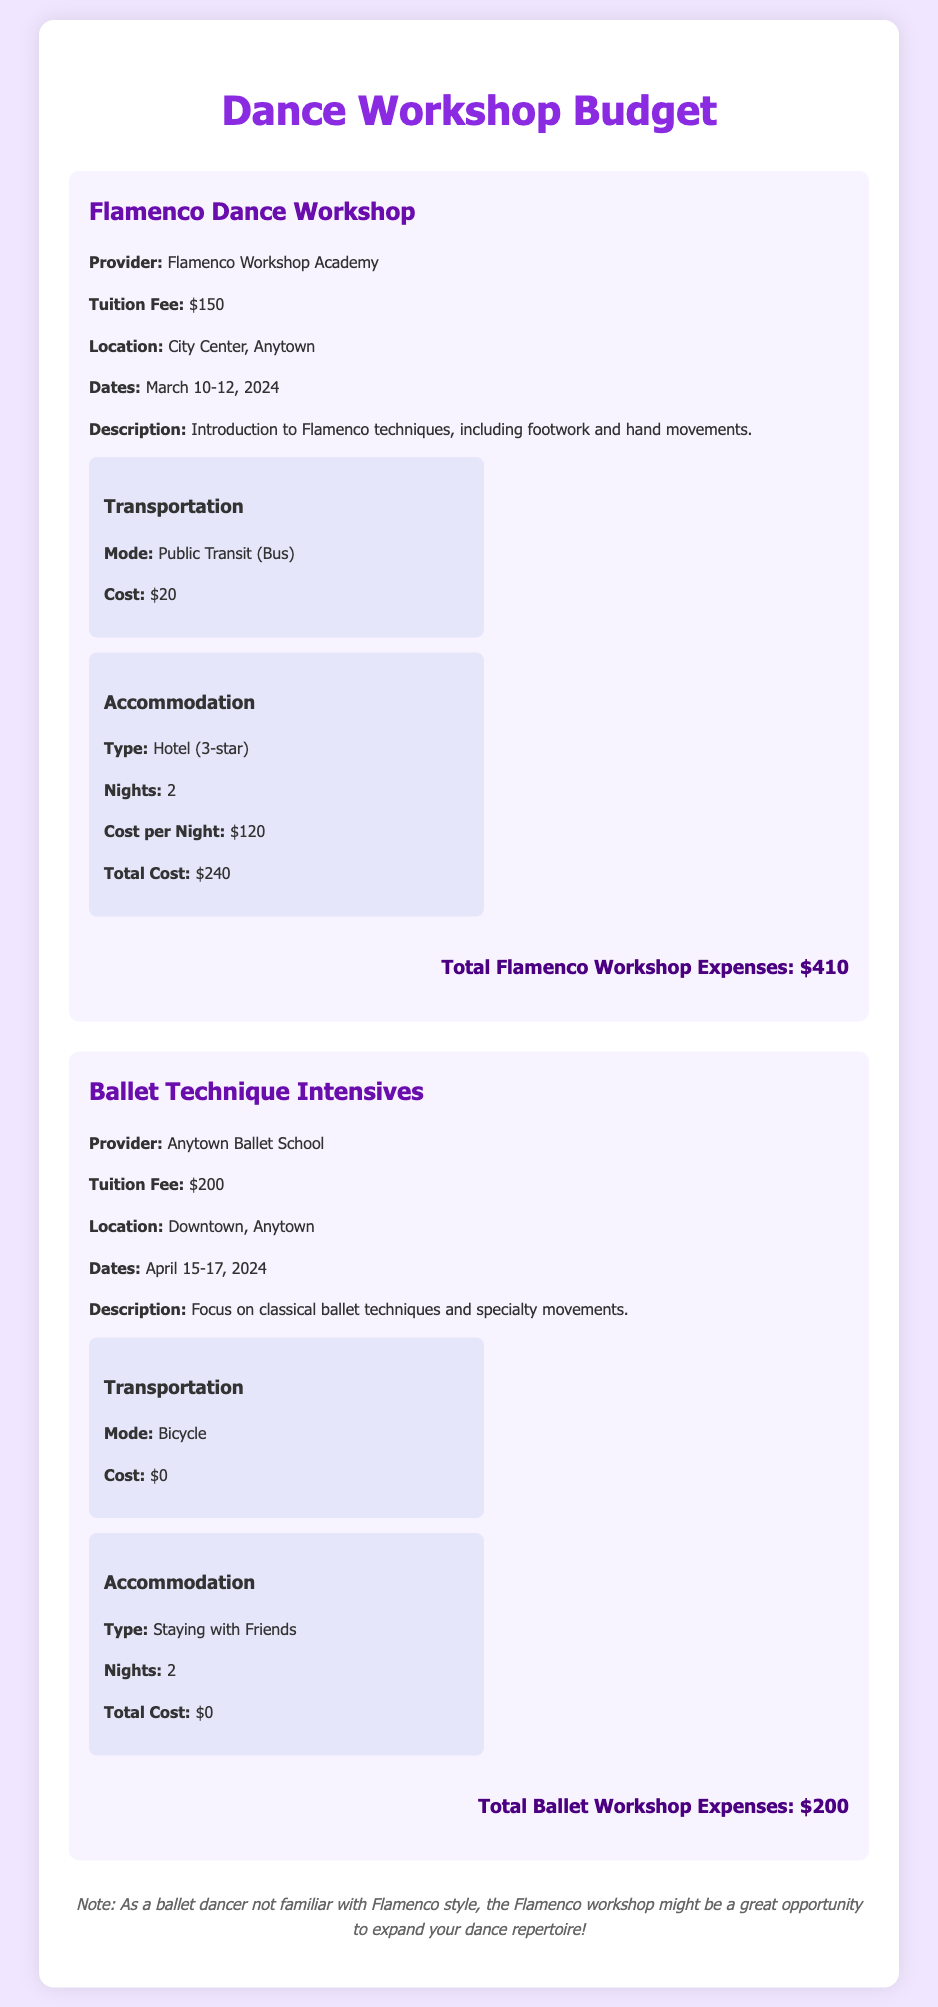What is the tuition fee for the Flamenco workshop? The tuition fee for the Flamenco workshop is stated in the document as $150.
Answer: $150 Where is the Ballet Technique Intensive located? The document specifies that the Ballet Technique Intensive is located in Downtown, Anytown.
Answer: Downtown, Anytown How many nights is the accommodation for the Flamenco workshop? The document indicates that the accommodation for the Flamenco workshop is for 2 nights.
Answer: 2 What is the total cost for the Ballet workshop? The total cost for the Ballet workshop is calculated and mentioned in the document as $200.
Answer: $200 What transportation mode will be used for the Flamenco workshop? The document lists public transit (bus) as the mode of transportation for the Flamenco workshop.
Answer: Public Transit (Bus) What is the total cost for the Flamenco workshop expenses? The document provides the total cost for Flamenco workshop expenses as $410.
Answer: $410 Which dance technique does the Ballet Workshop focus on? The document states that the Ballet Workshop focuses on classical ballet techniques and specialty movements.
Answer: Classical ballet techniques What type of accommodation is utilized for the Ballet workshop? According to the document, the accommodation for the Ballet workshop is staying with friends.
Answer: Staying with Friends When does the Flamenco dance workshop take place? The document lists the dates for the Flamenco dance workshop as March 10-12, 2024.
Answer: March 10-12, 2024 